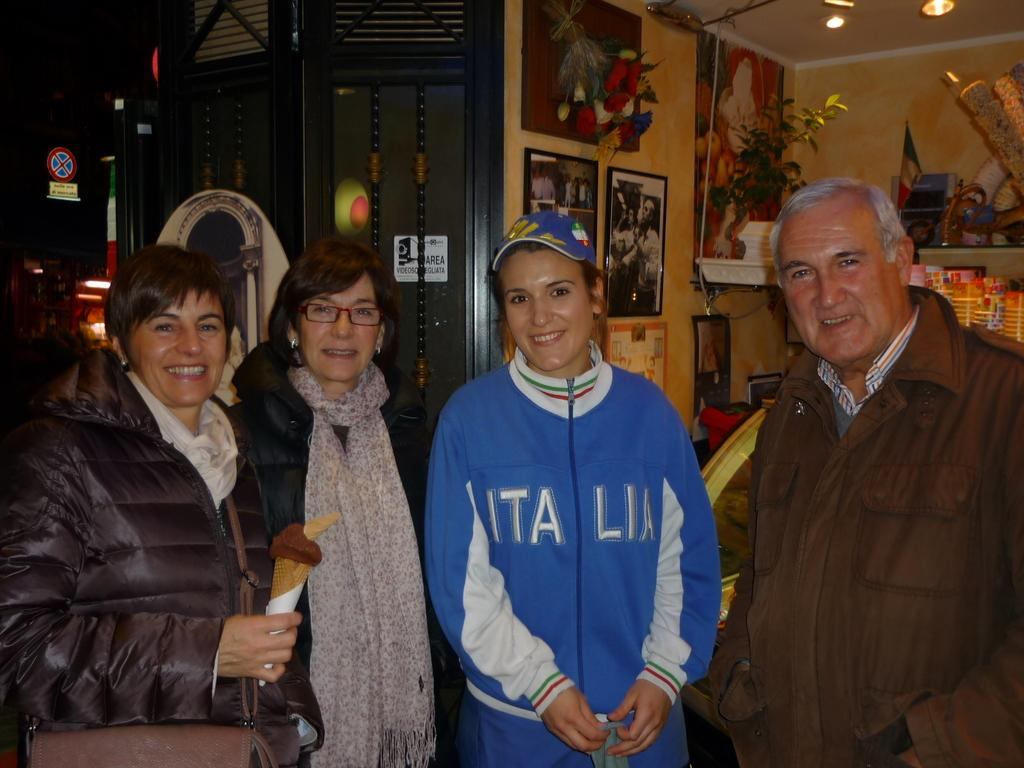<image>
Present a compact description of the photo's key features. A woman with a jacket with the word Italia on it is posing for a picture with three other people. 